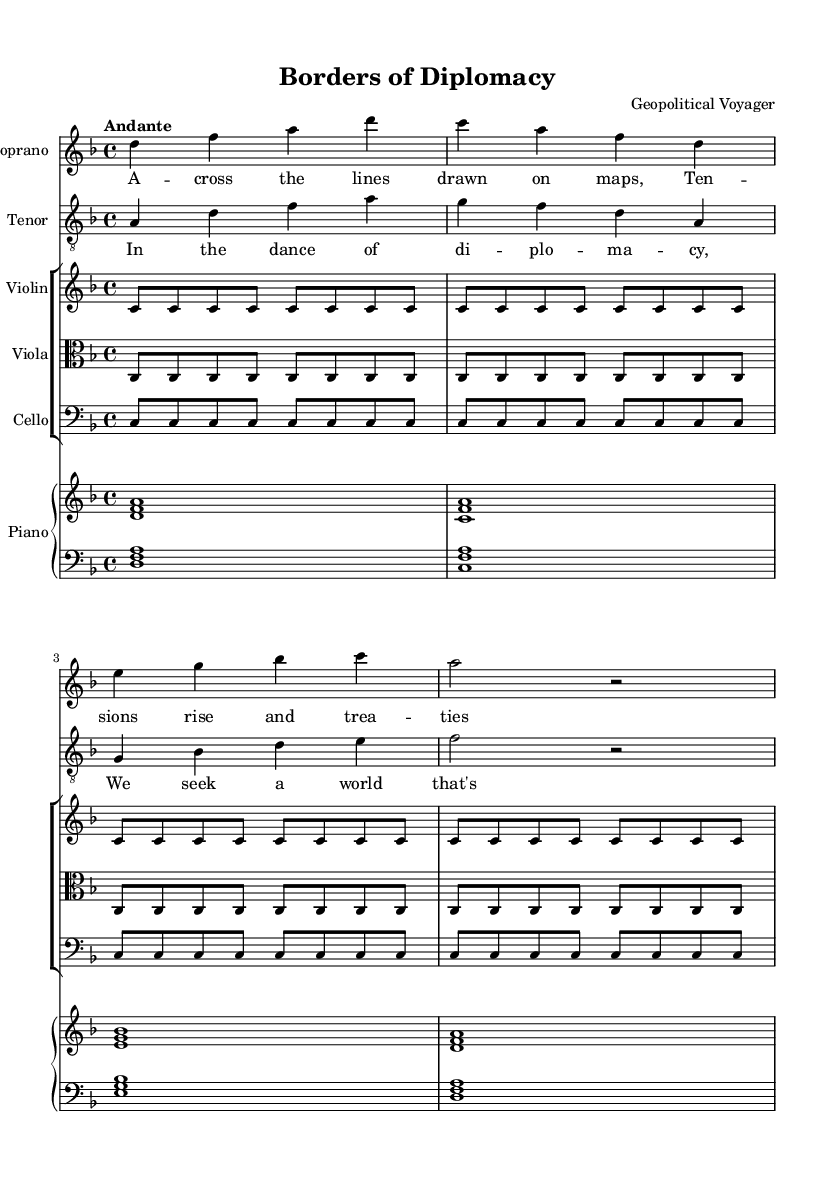What is the key signature of this music? The key signature is indicated at the beginning of the score, showing one flat. This means the piece is in D minor, which has one flat (C).
Answer: D minor What is the time signature of this music? The time signature is displayed at the start of the score, which is 4/4. This denotes that there are four beats in each measure, and the quarter note receives one beat.
Answer: 4/4 What is the tempo marking for this opera? The tempo marking is provided in Italian terms in the score. It states "Andante," which implies a moderate walking pace.
Answer: Andante Identify the primary theme of the lyrics. The lyrics describe the concept of borders and tensions in diplomacy, showcasing the intersection of national interests. The primary theme is about conflict and the pursuit of peace.
Answer: Borders and diplomacy How many measures does the soprano part consist of? By counting the measures for the soprano line throughout the score, we see that it comprises four measures, as marked by the grouping of notes and rests.
Answer: Four measures What instruments are included in the orchestration? The orchestration includes a soprano, tenor, violin, viola, cello, and piano, as identified in their respective staves and instrumental labels throughout the score.
Answer: Soprano, tenor, violin, viola, cello, piano 